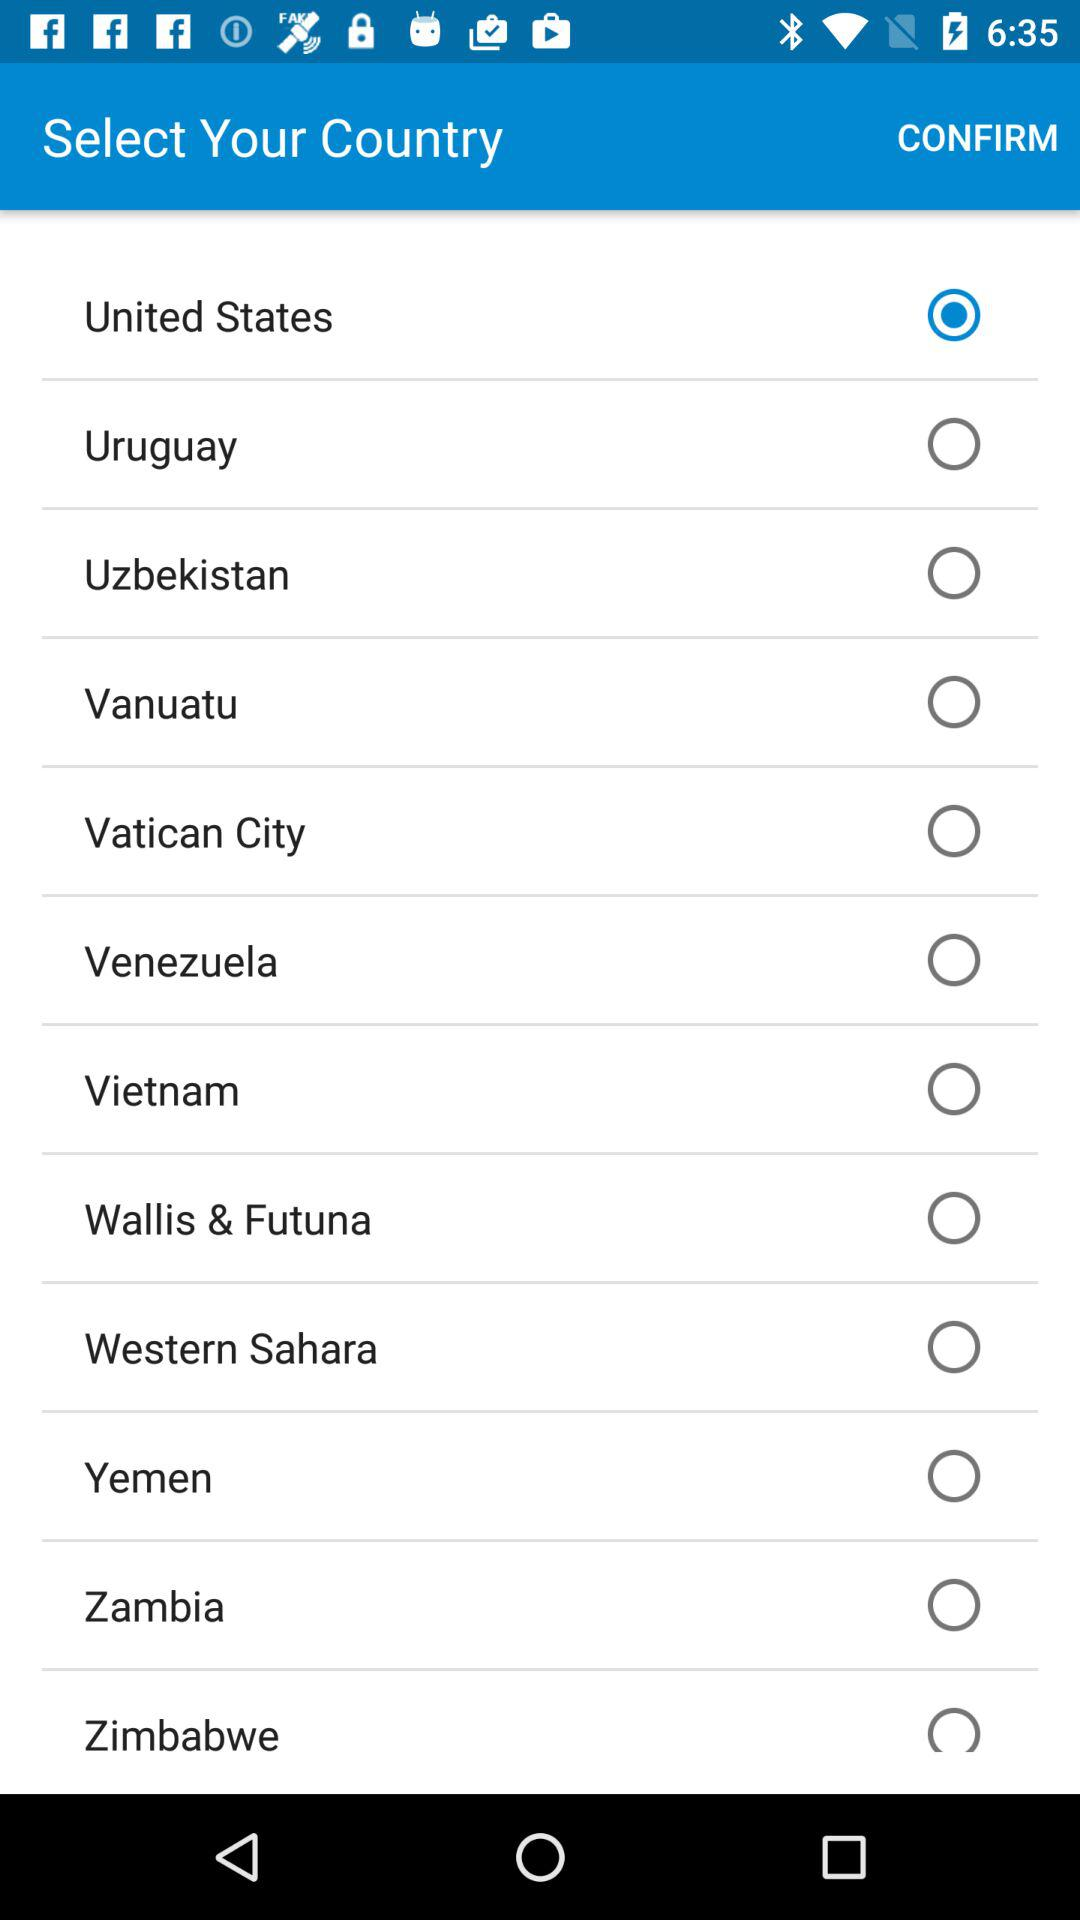Which country is selected? The selected country is the United States. 